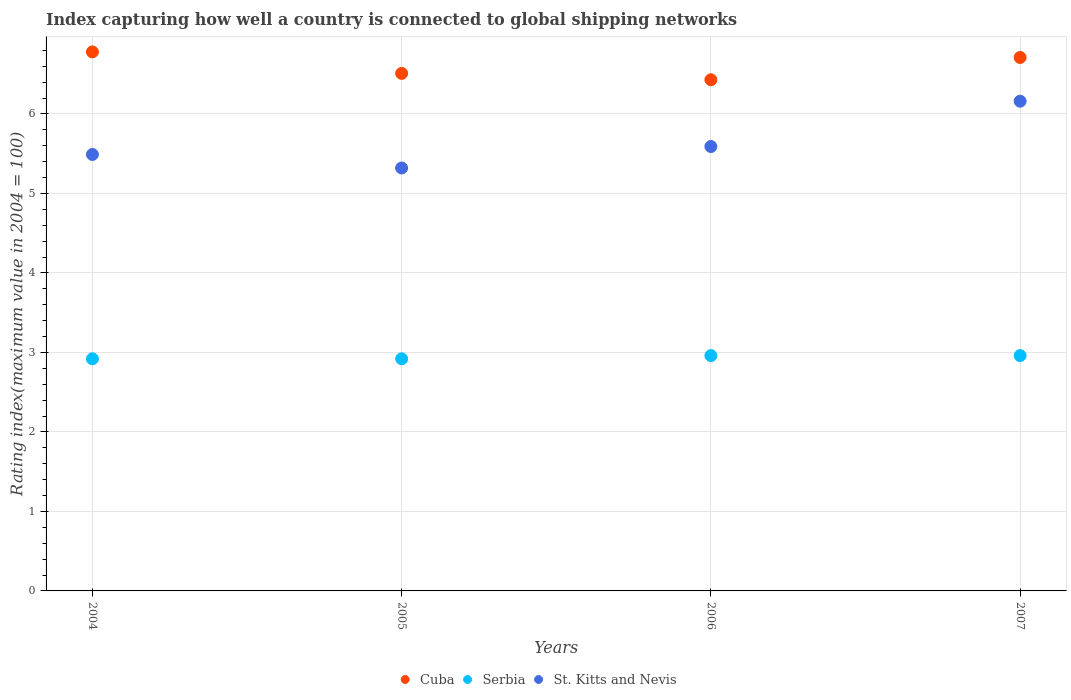How many different coloured dotlines are there?
Your response must be concise. 3. What is the rating index in Cuba in 2004?
Your response must be concise. 6.78. Across all years, what is the maximum rating index in Cuba?
Keep it short and to the point. 6.78. Across all years, what is the minimum rating index in Serbia?
Your answer should be compact. 2.92. In which year was the rating index in St. Kitts and Nevis maximum?
Your answer should be compact. 2007. In which year was the rating index in Serbia minimum?
Give a very brief answer. 2004. What is the total rating index in Serbia in the graph?
Your answer should be compact. 11.76. What is the difference between the rating index in Serbia in 2004 and that in 2006?
Keep it short and to the point. -0.04. What is the difference between the rating index in Serbia in 2006 and the rating index in Cuba in 2007?
Your answer should be very brief. -3.75. What is the average rating index in Serbia per year?
Your answer should be compact. 2.94. In the year 2006, what is the difference between the rating index in Cuba and rating index in Serbia?
Make the answer very short. 3.47. What is the ratio of the rating index in Serbia in 2004 to that in 2007?
Your answer should be compact. 0.99. Is the rating index in Serbia in 2006 less than that in 2007?
Offer a terse response. No. Is the difference between the rating index in Cuba in 2005 and 2006 greater than the difference between the rating index in Serbia in 2005 and 2006?
Offer a very short reply. Yes. What is the difference between the highest and the lowest rating index in St. Kitts and Nevis?
Provide a succinct answer. 0.84. In how many years, is the rating index in Serbia greater than the average rating index in Serbia taken over all years?
Offer a very short reply. 2. Is the sum of the rating index in Serbia in 2004 and 2007 greater than the maximum rating index in Cuba across all years?
Keep it short and to the point. No. Is the rating index in St. Kitts and Nevis strictly less than the rating index in Cuba over the years?
Offer a very short reply. Yes. How many dotlines are there?
Keep it short and to the point. 3. How many years are there in the graph?
Keep it short and to the point. 4. What is the difference between two consecutive major ticks on the Y-axis?
Give a very brief answer. 1. Where does the legend appear in the graph?
Provide a succinct answer. Bottom center. How many legend labels are there?
Give a very brief answer. 3. How are the legend labels stacked?
Your answer should be very brief. Horizontal. What is the title of the graph?
Ensure brevity in your answer.  Index capturing how well a country is connected to global shipping networks. Does "Paraguay" appear as one of the legend labels in the graph?
Provide a succinct answer. No. What is the label or title of the X-axis?
Your answer should be compact. Years. What is the label or title of the Y-axis?
Give a very brief answer. Rating index(maximum value in 2004 = 100). What is the Rating index(maximum value in 2004 = 100) of Cuba in 2004?
Provide a succinct answer. 6.78. What is the Rating index(maximum value in 2004 = 100) of Serbia in 2004?
Offer a terse response. 2.92. What is the Rating index(maximum value in 2004 = 100) of St. Kitts and Nevis in 2004?
Give a very brief answer. 5.49. What is the Rating index(maximum value in 2004 = 100) in Cuba in 2005?
Your answer should be very brief. 6.51. What is the Rating index(maximum value in 2004 = 100) of Serbia in 2005?
Keep it short and to the point. 2.92. What is the Rating index(maximum value in 2004 = 100) in St. Kitts and Nevis in 2005?
Offer a terse response. 5.32. What is the Rating index(maximum value in 2004 = 100) of Cuba in 2006?
Ensure brevity in your answer.  6.43. What is the Rating index(maximum value in 2004 = 100) of Serbia in 2006?
Offer a very short reply. 2.96. What is the Rating index(maximum value in 2004 = 100) of St. Kitts and Nevis in 2006?
Give a very brief answer. 5.59. What is the Rating index(maximum value in 2004 = 100) in Cuba in 2007?
Ensure brevity in your answer.  6.71. What is the Rating index(maximum value in 2004 = 100) in Serbia in 2007?
Your response must be concise. 2.96. What is the Rating index(maximum value in 2004 = 100) in St. Kitts and Nevis in 2007?
Offer a very short reply. 6.16. Across all years, what is the maximum Rating index(maximum value in 2004 = 100) in Cuba?
Provide a succinct answer. 6.78. Across all years, what is the maximum Rating index(maximum value in 2004 = 100) of Serbia?
Offer a terse response. 2.96. Across all years, what is the maximum Rating index(maximum value in 2004 = 100) of St. Kitts and Nevis?
Make the answer very short. 6.16. Across all years, what is the minimum Rating index(maximum value in 2004 = 100) of Cuba?
Your answer should be very brief. 6.43. Across all years, what is the minimum Rating index(maximum value in 2004 = 100) of Serbia?
Provide a succinct answer. 2.92. Across all years, what is the minimum Rating index(maximum value in 2004 = 100) in St. Kitts and Nevis?
Keep it short and to the point. 5.32. What is the total Rating index(maximum value in 2004 = 100) of Cuba in the graph?
Your answer should be compact. 26.43. What is the total Rating index(maximum value in 2004 = 100) in Serbia in the graph?
Offer a terse response. 11.76. What is the total Rating index(maximum value in 2004 = 100) in St. Kitts and Nevis in the graph?
Your answer should be compact. 22.56. What is the difference between the Rating index(maximum value in 2004 = 100) of Cuba in 2004 and that in 2005?
Provide a short and direct response. 0.27. What is the difference between the Rating index(maximum value in 2004 = 100) of Serbia in 2004 and that in 2005?
Provide a short and direct response. 0. What is the difference between the Rating index(maximum value in 2004 = 100) of St. Kitts and Nevis in 2004 and that in 2005?
Ensure brevity in your answer.  0.17. What is the difference between the Rating index(maximum value in 2004 = 100) of Serbia in 2004 and that in 2006?
Your response must be concise. -0.04. What is the difference between the Rating index(maximum value in 2004 = 100) of St. Kitts and Nevis in 2004 and that in 2006?
Make the answer very short. -0.1. What is the difference between the Rating index(maximum value in 2004 = 100) in Cuba in 2004 and that in 2007?
Your response must be concise. 0.07. What is the difference between the Rating index(maximum value in 2004 = 100) of Serbia in 2004 and that in 2007?
Ensure brevity in your answer.  -0.04. What is the difference between the Rating index(maximum value in 2004 = 100) in St. Kitts and Nevis in 2004 and that in 2007?
Your response must be concise. -0.67. What is the difference between the Rating index(maximum value in 2004 = 100) of Serbia in 2005 and that in 2006?
Keep it short and to the point. -0.04. What is the difference between the Rating index(maximum value in 2004 = 100) in St. Kitts and Nevis in 2005 and that in 2006?
Give a very brief answer. -0.27. What is the difference between the Rating index(maximum value in 2004 = 100) in Serbia in 2005 and that in 2007?
Offer a very short reply. -0.04. What is the difference between the Rating index(maximum value in 2004 = 100) of St. Kitts and Nevis in 2005 and that in 2007?
Keep it short and to the point. -0.84. What is the difference between the Rating index(maximum value in 2004 = 100) of Cuba in 2006 and that in 2007?
Give a very brief answer. -0.28. What is the difference between the Rating index(maximum value in 2004 = 100) in St. Kitts and Nevis in 2006 and that in 2007?
Make the answer very short. -0.57. What is the difference between the Rating index(maximum value in 2004 = 100) of Cuba in 2004 and the Rating index(maximum value in 2004 = 100) of Serbia in 2005?
Keep it short and to the point. 3.86. What is the difference between the Rating index(maximum value in 2004 = 100) of Cuba in 2004 and the Rating index(maximum value in 2004 = 100) of St. Kitts and Nevis in 2005?
Give a very brief answer. 1.46. What is the difference between the Rating index(maximum value in 2004 = 100) of Cuba in 2004 and the Rating index(maximum value in 2004 = 100) of Serbia in 2006?
Your answer should be compact. 3.82. What is the difference between the Rating index(maximum value in 2004 = 100) in Cuba in 2004 and the Rating index(maximum value in 2004 = 100) in St. Kitts and Nevis in 2006?
Make the answer very short. 1.19. What is the difference between the Rating index(maximum value in 2004 = 100) in Serbia in 2004 and the Rating index(maximum value in 2004 = 100) in St. Kitts and Nevis in 2006?
Your answer should be very brief. -2.67. What is the difference between the Rating index(maximum value in 2004 = 100) of Cuba in 2004 and the Rating index(maximum value in 2004 = 100) of Serbia in 2007?
Offer a very short reply. 3.82. What is the difference between the Rating index(maximum value in 2004 = 100) of Cuba in 2004 and the Rating index(maximum value in 2004 = 100) of St. Kitts and Nevis in 2007?
Give a very brief answer. 0.62. What is the difference between the Rating index(maximum value in 2004 = 100) of Serbia in 2004 and the Rating index(maximum value in 2004 = 100) of St. Kitts and Nevis in 2007?
Your answer should be compact. -3.24. What is the difference between the Rating index(maximum value in 2004 = 100) of Cuba in 2005 and the Rating index(maximum value in 2004 = 100) of Serbia in 2006?
Provide a succinct answer. 3.55. What is the difference between the Rating index(maximum value in 2004 = 100) of Serbia in 2005 and the Rating index(maximum value in 2004 = 100) of St. Kitts and Nevis in 2006?
Provide a succinct answer. -2.67. What is the difference between the Rating index(maximum value in 2004 = 100) in Cuba in 2005 and the Rating index(maximum value in 2004 = 100) in Serbia in 2007?
Ensure brevity in your answer.  3.55. What is the difference between the Rating index(maximum value in 2004 = 100) in Cuba in 2005 and the Rating index(maximum value in 2004 = 100) in St. Kitts and Nevis in 2007?
Ensure brevity in your answer.  0.35. What is the difference between the Rating index(maximum value in 2004 = 100) in Serbia in 2005 and the Rating index(maximum value in 2004 = 100) in St. Kitts and Nevis in 2007?
Your response must be concise. -3.24. What is the difference between the Rating index(maximum value in 2004 = 100) of Cuba in 2006 and the Rating index(maximum value in 2004 = 100) of Serbia in 2007?
Your answer should be very brief. 3.47. What is the difference between the Rating index(maximum value in 2004 = 100) of Cuba in 2006 and the Rating index(maximum value in 2004 = 100) of St. Kitts and Nevis in 2007?
Keep it short and to the point. 0.27. What is the average Rating index(maximum value in 2004 = 100) in Cuba per year?
Ensure brevity in your answer.  6.61. What is the average Rating index(maximum value in 2004 = 100) in Serbia per year?
Keep it short and to the point. 2.94. What is the average Rating index(maximum value in 2004 = 100) in St. Kitts and Nevis per year?
Make the answer very short. 5.64. In the year 2004, what is the difference between the Rating index(maximum value in 2004 = 100) of Cuba and Rating index(maximum value in 2004 = 100) of Serbia?
Make the answer very short. 3.86. In the year 2004, what is the difference between the Rating index(maximum value in 2004 = 100) in Cuba and Rating index(maximum value in 2004 = 100) in St. Kitts and Nevis?
Your answer should be very brief. 1.29. In the year 2004, what is the difference between the Rating index(maximum value in 2004 = 100) of Serbia and Rating index(maximum value in 2004 = 100) of St. Kitts and Nevis?
Your answer should be very brief. -2.57. In the year 2005, what is the difference between the Rating index(maximum value in 2004 = 100) in Cuba and Rating index(maximum value in 2004 = 100) in Serbia?
Your answer should be compact. 3.59. In the year 2005, what is the difference between the Rating index(maximum value in 2004 = 100) in Cuba and Rating index(maximum value in 2004 = 100) in St. Kitts and Nevis?
Make the answer very short. 1.19. In the year 2005, what is the difference between the Rating index(maximum value in 2004 = 100) in Serbia and Rating index(maximum value in 2004 = 100) in St. Kitts and Nevis?
Keep it short and to the point. -2.4. In the year 2006, what is the difference between the Rating index(maximum value in 2004 = 100) in Cuba and Rating index(maximum value in 2004 = 100) in Serbia?
Your answer should be very brief. 3.47. In the year 2006, what is the difference between the Rating index(maximum value in 2004 = 100) in Cuba and Rating index(maximum value in 2004 = 100) in St. Kitts and Nevis?
Offer a very short reply. 0.84. In the year 2006, what is the difference between the Rating index(maximum value in 2004 = 100) of Serbia and Rating index(maximum value in 2004 = 100) of St. Kitts and Nevis?
Your answer should be very brief. -2.63. In the year 2007, what is the difference between the Rating index(maximum value in 2004 = 100) in Cuba and Rating index(maximum value in 2004 = 100) in Serbia?
Offer a very short reply. 3.75. In the year 2007, what is the difference between the Rating index(maximum value in 2004 = 100) in Cuba and Rating index(maximum value in 2004 = 100) in St. Kitts and Nevis?
Your answer should be very brief. 0.55. What is the ratio of the Rating index(maximum value in 2004 = 100) of Cuba in 2004 to that in 2005?
Your answer should be very brief. 1.04. What is the ratio of the Rating index(maximum value in 2004 = 100) in Serbia in 2004 to that in 2005?
Give a very brief answer. 1. What is the ratio of the Rating index(maximum value in 2004 = 100) of St. Kitts and Nevis in 2004 to that in 2005?
Offer a terse response. 1.03. What is the ratio of the Rating index(maximum value in 2004 = 100) of Cuba in 2004 to that in 2006?
Give a very brief answer. 1.05. What is the ratio of the Rating index(maximum value in 2004 = 100) in Serbia in 2004 to that in 2006?
Keep it short and to the point. 0.99. What is the ratio of the Rating index(maximum value in 2004 = 100) of St. Kitts and Nevis in 2004 to that in 2006?
Make the answer very short. 0.98. What is the ratio of the Rating index(maximum value in 2004 = 100) of Cuba in 2004 to that in 2007?
Offer a very short reply. 1.01. What is the ratio of the Rating index(maximum value in 2004 = 100) in Serbia in 2004 to that in 2007?
Give a very brief answer. 0.99. What is the ratio of the Rating index(maximum value in 2004 = 100) of St. Kitts and Nevis in 2004 to that in 2007?
Provide a short and direct response. 0.89. What is the ratio of the Rating index(maximum value in 2004 = 100) of Cuba in 2005 to that in 2006?
Your response must be concise. 1.01. What is the ratio of the Rating index(maximum value in 2004 = 100) in Serbia in 2005 to that in 2006?
Provide a succinct answer. 0.99. What is the ratio of the Rating index(maximum value in 2004 = 100) of St. Kitts and Nevis in 2005 to that in 2006?
Your answer should be very brief. 0.95. What is the ratio of the Rating index(maximum value in 2004 = 100) in Cuba in 2005 to that in 2007?
Your answer should be very brief. 0.97. What is the ratio of the Rating index(maximum value in 2004 = 100) of Serbia in 2005 to that in 2007?
Provide a succinct answer. 0.99. What is the ratio of the Rating index(maximum value in 2004 = 100) of St. Kitts and Nevis in 2005 to that in 2007?
Keep it short and to the point. 0.86. What is the ratio of the Rating index(maximum value in 2004 = 100) of Cuba in 2006 to that in 2007?
Provide a short and direct response. 0.96. What is the ratio of the Rating index(maximum value in 2004 = 100) in Serbia in 2006 to that in 2007?
Keep it short and to the point. 1. What is the ratio of the Rating index(maximum value in 2004 = 100) in St. Kitts and Nevis in 2006 to that in 2007?
Keep it short and to the point. 0.91. What is the difference between the highest and the second highest Rating index(maximum value in 2004 = 100) in Cuba?
Provide a short and direct response. 0.07. What is the difference between the highest and the second highest Rating index(maximum value in 2004 = 100) of St. Kitts and Nevis?
Offer a very short reply. 0.57. What is the difference between the highest and the lowest Rating index(maximum value in 2004 = 100) in St. Kitts and Nevis?
Make the answer very short. 0.84. 